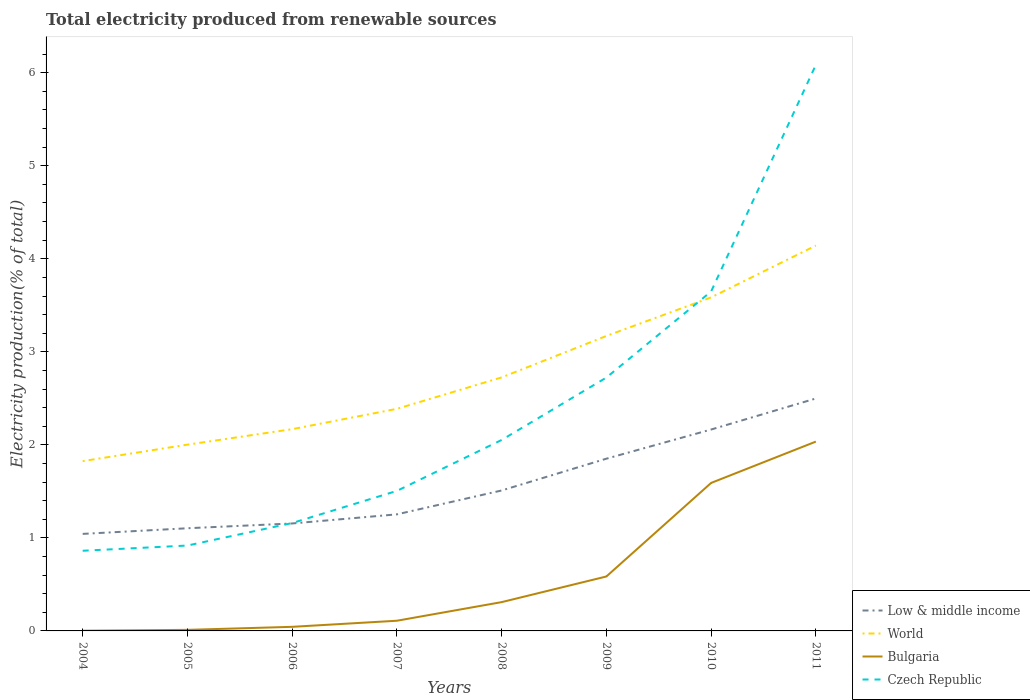Is the number of lines equal to the number of legend labels?
Offer a terse response. Yes. Across all years, what is the maximum total electricity produced in Bulgaria?
Offer a terse response. 0. In which year was the total electricity produced in Czech Republic maximum?
Your answer should be very brief. 2004. What is the total total electricity produced in World in the graph?
Provide a succinct answer. -0.17. What is the difference between the highest and the second highest total electricity produced in Bulgaria?
Keep it short and to the point. 2.03. What is the difference between the highest and the lowest total electricity produced in World?
Keep it short and to the point. 3. Is the total electricity produced in Czech Republic strictly greater than the total electricity produced in Bulgaria over the years?
Provide a short and direct response. No. How many lines are there?
Offer a very short reply. 4. How many years are there in the graph?
Make the answer very short. 8. Are the values on the major ticks of Y-axis written in scientific E-notation?
Your response must be concise. No. Does the graph contain grids?
Offer a terse response. No. Where does the legend appear in the graph?
Give a very brief answer. Bottom right. How many legend labels are there?
Give a very brief answer. 4. How are the legend labels stacked?
Offer a terse response. Vertical. What is the title of the graph?
Ensure brevity in your answer.  Total electricity produced from renewable sources. What is the label or title of the X-axis?
Offer a terse response. Years. What is the label or title of the Y-axis?
Give a very brief answer. Electricity production(% of total). What is the Electricity production(% of total) in Low & middle income in 2004?
Ensure brevity in your answer.  1.04. What is the Electricity production(% of total) of World in 2004?
Give a very brief answer. 1.83. What is the Electricity production(% of total) of Bulgaria in 2004?
Your response must be concise. 0. What is the Electricity production(% of total) of Czech Republic in 2004?
Keep it short and to the point. 0.86. What is the Electricity production(% of total) of Low & middle income in 2005?
Ensure brevity in your answer.  1.1. What is the Electricity production(% of total) in World in 2005?
Keep it short and to the point. 2. What is the Electricity production(% of total) of Bulgaria in 2005?
Your response must be concise. 0.01. What is the Electricity production(% of total) of Czech Republic in 2005?
Give a very brief answer. 0.92. What is the Electricity production(% of total) in Low & middle income in 2006?
Give a very brief answer. 1.16. What is the Electricity production(% of total) of World in 2006?
Provide a short and direct response. 2.17. What is the Electricity production(% of total) of Bulgaria in 2006?
Keep it short and to the point. 0.04. What is the Electricity production(% of total) of Czech Republic in 2006?
Your response must be concise. 1.16. What is the Electricity production(% of total) in Low & middle income in 2007?
Your response must be concise. 1.25. What is the Electricity production(% of total) in World in 2007?
Provide a succinct answer. 2.39. What is the Electricity production(% of total) in Bulgaria in 2007?
Your response must be concise. 0.11. What is the Electricity production(% of total) of Czech Republic in 2007?
Your response must be concise. 1.51. What is the Electricity production(% of total) of Low & middle income in 2008?
Your answer should be compact. 1.51. What is the Electricity production(% of total) of World in 2008?
Provide a succinct answer. 2.72. What is the Electricity production(% of total) of Bulgaria in 2008?
Offer a terse response. 0.31. What is the Electricity production(% of total) of Czech Republic in 2008?
Make the answer very short. 2.05. What is the Electricity production(% of total) in Low & middle income in 2009?
Your response must be concise. 1.85. What is the Electricity production(% of total) of World in 2009?
Give a very brief answer. 3.17. What is the Electricity production(% of total) of Bulgaria in 2009?
Your response must be concise. 0.59. What is the Electricity production(% of total) of Czech Republic in 2009?
Offer a very short reply. 2.72. What is the Electricity production(% of total) in Low & middle income in 2010?
Make the answer very short. 2.16. What is the Electricity production(% of total) in World in 2010?
Give a very brief answer. 3.58. What is the Electricity production(% of total) in Bulgaria in 2010?
Provide a short and direct response. 1.59. What is the Electricity production(% of total) in Czech Republic in 2010?
Offer a terse response. 3.65. What is the Electricity production(% of total) in Low & middle income in 2011?
Your answer should be compact. 2.5. What is the Electricity production(% of total) of World in 2011?
Keep it short and to the point. 4.14. What is the Electricity production(% of total) in Bulgaria in 2011?
Ensure brevity in your answer.  2.04. What is the Electricity production(% of total) in Czech Republic in 2011?
Offer a very short reply. 6.08. Across all years, what is the maximum Electricity production(% of total) of Low & middle income?
Offer a very short reply. 2.5. Across all years, what is the maximum Electricity production(% of total) of World?
Your answer should be compact. 4.14. Across all years, what is the maximum Electricity production(% of total) of Bulgaria?
Provide a succinct answer. 2.04. Across all years, what is the maximum Electricity production(% of total) in Czech Republic?
Provide a succinct answer. 6.08. Across all years, what is the minimum Electricity production(% of total) in Low & middle income?
Offer a terse response. 1.04. Across all years, what is the minimum Electricity production(% of total) in World?
Provide a short and direct response. 1.83. Across all years, what is the minimum Electricity production(% of total) in Bulgaria?
Ensure brevity in your answer.  0. Across all years, what is the minimum Electricity production(% of total) of Czech Republic?
Provide a short and direct response. 0.86. What is the total Electricity production(% of total) in Low & middle income in the graph?
Offer a very short reply. 12.58. What is the total Electricity production(% of total) in World in the graph?
Keep it short and to the point. 22.01. What is the total Electricity production(% of total) in Bulgaria in the graph?
Offer a very short reply. 4.69. What is the total Electricity production(% of total) in Czech Republic in the graph?
Provide a short and direct response. 18.95. What is the difference between the Electricity production(% of total) of Low & middle income in 2004 and that in 2005?
Make the answer very short. -0.06. What is the difference between the Electricity production(% of total) in World in 2004 and that in 2005?
Ensure brevity in your answer.  -0.18. What is the difference between the Electricity production(% of total) of Bulgaria in 2004 and that in 2005?
Offer a terse response. -0.01. What is the difference between the Electricity production(% of total) of Czech Republic in 2004 and that in 2005?
Give a very brief answer. -0.06. What is the difference between the Electricity production(% of total) of Low & middle income in 2004 and that in 2006?
Provide a short and direct response. -0.11. What is the difference between the Electricity production(% of total) of World in 2004 and that in 2006?
Provide a short and direct response. -0.34. What is the difference between the Electricity production(% of total) of Bulgaria in 2004 and that in 2006?
Offer a terse response. -0.04. What is the difference between the Electricity production(% of total) in Czech Republic in 2004 and that in 2006?
Provide a succinct answer. -0.3. What is the difference between the Electricity production(% of total) of Low & middle income in 2004 and that in 2007?
Keep it short and to the point. -0.21. What is the difference between the Electricity production(% of total) of World in 2004 and that in 2007?
Offer a terse response. -0.56. What is the difference between the Electricity production(% of total) of Bulgaria in 2004 and that in 2007?
Offer a terse response. -0.11. What is the difference between the Electricity production(% of total) in Czech Republic in 2004 and that in 2007?
Your answer should be very brief. -0.64. What is the difference between the Electricity production(% of total) in Low & middle income in 2004 and that in 2008?
Ensure brevity in your answer.  -0.47. What is the difference between the Electricity production(% of total) of World in 2004 and that in 2008?
Provide a succinct answer. -0.9. What is the difference between the Electricity production(% of total) in Bulgaria in 2004 and that in 2008?
Your response must be concise. -0.31. What is the difference between the Electricity production(% of total) in Czech Republic in 2004 and that in 2008?
Give a very brief answer. -1.19. What is the difference between the Electricity production(% of total) of Low & middle income in 2004 and that in 2009?
Your response must be concise. -0.81. What is the difference between the Electricity production(% of total) of World in 2004 and that in 2009?
Your answer should be compact. -1.35. What is the difference between the Electricity production(% of total) in Bulgaria in 2004 and that in 2009?
Your answer should be compact. -0.58. What is the difference between the Electricity production(% of total) in Czech Republic in 2004 and that in 2009?
Keep it short and to the point. -1.86. What is the difference between the Electricity production(% of total) in Low & middle income in 2004 and that in 2010?
Ensure brevity in your answer.  -1.12. What is the difference between the Electricity production(% of total) of World in 2004 and that in 2010?
Offer a very short reply. -1.76. What is the difference between the Electricity production(% of total) in Bulgaria in 2004 and that in 2010?
Provide a short and direct response. -1.59. What is the difference between the Electricity production(% of total) of Czech Republic in 2004 and that in 2010?
Ensure brevity in your answer.  -2.79. What is the difference between the Electricity production(% of total) of Low & middle income in 2004 and that in 2011?
Your response must be concise. -1.46. What is the difference between the Electricity production(% of total) of World in 2004 and that in 2011?
Your answer should be very brief. -2.32. What is the difference between the Electricity production(% of total) in Bulgaria in 2004 and that in 2011?
Ensure brevity in your answer.  -2.03. What is the difference between the Electricity production(% of total) of Czech Republic in 2004 and that in 2011?
Offer a terse response. -5.22. What is the difference between the Electricity production(% of total) of Low & middle income in 2005 and that in 2006?
Give a very brief answer. -0.05. What is the difference between the Electricity production(% of total) of World in 2005 and that in 2006?
Provide a short and direct response. -0.17. What is the difference between the Electricity production(% of total) of Bulgaria in 2005 and that in 2006?
Give a very brief answer. -0.03. What is the difference between the Electricity production(% of total) of Czech Republic in 2005 and that in 2006?
Provide a short and direct response. -0.24. What is the difference between the Electricity production(% of total) of Low & middle income in 2005 and that in 2007?
Your response must be concise. -0.15. What is the difference between the Electricity production(% of total) in World in 2005 and that in 2007?
Your response must be concise. -0.39. What is the difference between the Electricity production(% of total) of Bulgaria in 2005 and that in 2007?
Your answer should be very brief. -0.1. What is the difference between the Electricity production(% of total) of Czech Republic in 2005 and that in 2007?
Ensure brevity in your answer.  -0.59. What is the difference between the Electricity production(% of total) in Low & middle income in 2005 and that in 2008?
Keep it short and to the point. -0.41. What is the difference between the Electricity production(% of total) of World in 2005 and that in 2008?
Give a very brief answer. -0.72. What is the difference between the Electricity production(% of total) of Bulgaria in 2005 and that in 2008?
Provide a short and direct response. -0.3. What is the difference between the Electricity production(% of total) in Czech Republic in 2005 and that in 2008?
Offer a terse response. -1.13. What is the difference between the Electricity production(% of total) of Low & middle income in 2005 and that in 2009?
Your answer should be compact. -0.75. What is the difference between the Electricity production(% of total) in World in 2005 and that in 2009?
Keep it short and to the point. -1.17. What is the difference between the Electricity production(% of total) in Bulgaria in 2005 and that in 2009?
Ensure brevity in your answer.  -0.57. What is the difference between the Electricity production(% of total) of Czech Republic in 2005 and that in 2009?
Make the answer very short. -1.81. What is the difference between the Electricity production(% of total) in Low & middle income in 2005 and that in 2010?
Offer a terse response. -1.06. What is the difference between the Electricity production(% of total) in World in 2005 and that in 2010?
Provide a succinct answer. -1.58. What is the difference between the Electricity production(% of total) of Bulgaria in 2005 and that in 2010?
Your response must be concise. -1.58. What is the difference between the Electricity production(% of total) in Czech Republic in 2005 and that in 2010?
Offer a terse response. -2.73. What is the difference between the Electricity production(% of total) in Low & middle income in 2005 and that in 2011?
Your response must be concise. -1.39. What is the difference between the Electricity production(% of total) in World in 2005 and that in 2011?
Offer a very short reply. -2.14. What is the difference between the Electricity production(% of total) in Bulgaria in 2005 and that in 2011?
Your response must be concise. -2.02. What is the difference between the Electricity production(% of total) in Czech Republic in 2005 and that in 2011?
Offer a terse response. -5.17. What is the difference between the Electricity production(% of total) in Low & middle income in 2006 and that in 2007?
Keep it short and to the point. -0.1. What is the difference between the Electricity production(% of total) of World in 2006 and that in 2007?
Your response must be concise. -0.22. What is the difference between the Electricity production(% of total) in Bulgaria in 2006 and that in 2007?
Provide a succinct answer. -0.07. What is the difference between the Electricity production(% of total) of Czech Republic in 2006 and that in 2007?
Offer a very short reply. -0.35. What is the difference between the Electricity production(% of total) of Low & middle income in 2006 and that in 2008?
Your response must be concise. -0.35. What is the difference between the Electricity production(% of total) in World in 2006 and that in 2008?
Your answer should be very brief. -0.56. What is the difference between the Electricity production(% of total) in Bulgaria in 2006 and that in 2008?
Your answer should be very brief. -0.27. What is the difference between the Electricity production(% of total) in Czech Republic in 2006 and that in 2008?
Offer a very short reply. -0.89. What is the difference between the Electricity production(% of total) of Low & middle income in 2006 and that in 2009?
Offer a very short reply. -0.7. What is the difference between the Electricity production(% of total) of World in 2006 and that in 2009?
Offer a terse response. -1. What is the difference between the Electricity production(% of total) in Bulgaria in 2006 and that in 2009?
Give a very brief answer. -0.54. What is the difference between the Electricity production(% of total) in Czech Republic in 2006 and that in 2009?
Your answer should be compact. -1.56. What is the difference between the Electricity production(% of total) in Low & middle income in 2006 and that in 2010?
Make the answer very short. -1.01. What is the difference between the Electricity production(% of total) of World in 2006 and that in 2010?
Make the answer very short. -1.42. What is the difference between the Electricity production(% of total) in Bulgaria in 2006 and that in 2010?
Provide a short and direct response. -1.55. What is the difference between the Electricity production(% of total) of Czech Republic in 2006 and that in 2010?
Your answer should be compact. -2.49. What is the difference between the Electricity production(% of total) in Low & middle income in 2006 and that in 2011?
Your response must be concise. -1.34. What is the difference between the Electricity production(% of total) of World in 2006 and that in 2011?
Provide a short and direct response. -1.97. What is the difference between the Electricity production(% of total) of Bulgaria in 2006 and that in 2011?
Provide a short and direct response. -1.99. What is the difference between the Electricity production(% of total) in Czech Republic in 2006 and that in 2011?
Give a very brief answer. -4.92. What is the difference between the Electricity production(% of total) of Low & middle income in 2007 and that in 2008?
Offer a terse response. -0.26. What is the difference between the Electricity production(% of total) in World in 2007 and that in 2008?
Ensure brevity in your answer.  -0.34. What is the difference between the Electricity production(% of total) of Bulgaria in 2007 and that in 2008?
Provide a short and direct response. -0.2. What is the difference between the Electricity production(% of total) in Czech Republic in 2007 and that in 2008?
Keep it short and to the point. -0.55. What is the difference between the Electricity production(% of total) of Low & middle income in 2007 and that in 2009?
Provide a succinct answer. -0.6. What is the difference between the Electricity production(% of total) of World in 2007 and that in 2009?
Ensure brevity in your answer.  -0.78. What is the difference between the Electricity production(% of total) in Bulgaria in 2007 and that in 2009?
Your answer should be very brief. -0.48. What is the difference between the Electricity production(% of total) in Czech Republic in 2007 and that in 2009?
Provide a short and direct response. -1.22. What is the difference between the Electricity production(% of total) in Low & middle income in 2007 and that in 2010?
Make the answer very short. -0.91. What is the difference between the Electricity production(% of total) of World in 2007 and that in 2010?
Your answer should be very brief. -1.2. What is the difference between the Electricity production(% of total) of Bulgaria in 2007 and that in 2010?
Offer a very short reply. -1.48. What is the difference between the Electricity production(% of total) in Czech Republic in 2007 and that in 2010?
Ensure brevity in your answer.  -2.14. What is the difference between the Electricity production(% of total) of Low & middle income in 2007 and that in 2011?
Give a very brief answer. -1.25. What is the difference between the Electricity production(% of total) of World in 2007 and that in 2011?
Your answer should be very brief. -1.75. What is the difference between the Electricity production(% of total) in Bulgaria in 2007 and that in 2011?
Give a very brief answer. -1.93. What is the difference between the Electricity production(% of total) of Czech Republic in 2007 and that in 2011?
Provide a succinct answer. -4.58. What is the difference between the Electricity production(% of total) of Low & middle income in 2008 and that in 2009?
Give a very brief answer. -0.34. What is the difference between the Electricity production(% of total) of World in 2008 and that in 2009?
Make the answer very short. -0.45. What is the difference between the Electricity production(% of total) in Bulgaria in 2008 and that in 2009?
Ensure brevity in your answer.  -0.28. What is the difference between the Electricity production(% of total) of Czech Republic in 2008 and that in 2009?
Make the answer very short. -0.67. What is the difference between the Electricity production(% of total) of Low & middle income in 2008 and that in 2010?
Keep it short and to the point. -0.66. What is the difference between the Electricity production(% of total) in World in 2008 and that in 2010?
Make the answer very short. -0.86. What is the difference between the Electricity production(% of total) in Bulgaria in 2008 and that in 2010?
Your response must be concise. -1.28. What is the difference between the Electricity production(% of total) of Czech Republic in 2008 and that in 2010?
Your answer should be compact. -1.6. What is the difference between the Electricity production(% of total) in Low & middle income in 2008 and that in 2011?
Your answer should be compact. -0.99. What is the difference between the Electricity production(% of total) of World in 2008 and that in 2011?
Your answer should be compact. -1.42. What is the difference between the Electricity production(% of total) in Bulgaria in 2008 and that in 2011?
Provide a succinct answer. -1.73. What is the difference between the Electricity production(% of total) in Czech Republic in 2008 and that in 2011?
Your answer should be very brief. -4.03. What is the difference between the Electricity production(% of total) of Low & middle income in 2009 and that in 2010?
Your response must be concise. -0.31. What is the difference between the Electricity production(% of total) of World in 2009 and that in 2010?
Make the answer very short. -0.41. What is the difference between the Electricity production(% of total) of Bulgaria in 2009 and that in 2010?
Make the answer very short. -1.01. What is the difference between the Electricity production(% of total) in Czech Republic in 2009 and that in 2010?
Your answer should be compact. -0.93. What is the difference between the Electricity production(% of total) in Low & middle income in 2009 and that in 2011?
Your answer should be compact. -0.65. What is the difference between the Electricity production(% of total) of World in 2009 and that in 2011?
Provide a succinct answer. -0.97. What is the difference between the Electricity production(% of total) of Bulgaria in 2009 and that in 2011?
Your answer should be compact. -1.45. What is the difference between the Electricity production(% of total) of Czech Republic in 2009 and that in 2011?
Your answer should be very brief. -3.36. What is the difference between the Electricity production(% of total) in Low & middle income in 2010 and that in 2011?
Ensure brevity in your answer.  -0.33. What is the difference between the Electricity production(% of total) in World in 2010 and that in 2011?
Make the answer very short. -0.56. What is the difference between the Electricity production(% of total) of Bulgaria in 2010 and that in 2011?
Provide a short and direct response. -0.44. What is the difference between the Electricity production(% of total) in Czech Republic in 2010 and that in 2011?
Keep it short and to the point. -2.44. What is the difference between the Electricity production(% of total) of Low & middle income in 2004 and the Electricity production(% of total) of World in 2005?
Provide a succinct answer. -0.96. What is the difference between the Electricity production(% of total) of Low & middle income in 2004 and the Electricity production(% of total) of Bulgaria in 2005?
Make the answer very short. 1.03. What is the difference between the Electricity production(% of total) in Low & middle income in 2004 and the Electricity production(% of total) in Czech Republic in 2005?
Your answer should be very brief. 0.13. What is the difference between the Electricity production(% of total) of World in 2004 and the Electricity production(% of total) of Bulgaria in 2005?
Give a very brief answer. 1.81. What is the difference between the Electricity production(% of total) of World in 2004 and the Electricity production(% of total) of Czech Republic in 2005?
Provide a short and direct response. 0.91. What is the difference between the Electricity production(% of total) in Bulgaria in 2004 and the Electricity production(% of total) in Czech Republic in 2005?
Your response must be concise. -0.92. What is the difference between the Electricity production(% of total) in Low & middle income in 2004 and the Electricity production(% of total) in World in 2006?
Your response must be concise. -1.13. What is the difference between the Electricity production(% of total) of Low & middle income in 2004 and the Electricity production(% of total) of Bulgaria in 2006?
Ensure brevity in your answer.  1. What is the difference between the Electricity production(% of total) of Low & middle income in 2004 and the Electricity production(% of total) of Czech Republic in 2006?
Your answer should be compact. -0.12. What is the difference between the Electricity production(% of total) in World in 2004 and the Electricity production(% of total) in Bulgaria in 2006?
Give a very brief answer. 1.78. What is the difference between the Electricity production(% of total) in World in 2004 and the Electricity production(% of total) in Czech Republic in 2006?
Your answer should be compact. 0.67. What is the difference between the Electricity production(% of total) of Bulgaria in 2004 and the Electricity production(% of total) of Czech Republic in 2006?
Ensure brevity in your answer.  -1.16. What is the difference between the Electricity production(% of total) in Low & middle income in 2004 and the Electricity production(% of total) in World in 2007?
Provide a short and direct response. -1.34. What is the difference between the Electricity production(% of total) of Low & middle income in 2004 and the Electricity production(% of total) of Bulgaria in 2007?
Your answer should be very brief. 0.93. What is the difference between the Electricity production(% of total) of Low & middle income in 2004 and the Electricity production(% of total) of Czech Republic in 2007?
Give a very brief answer. -0.46. What is the difference between the Electricity production(% of total) of World in 2004 and the Electricity production(% of total) of Bulgaria in 2007?
Give a very brief answer. 1.72. What is the difference between the Electricity production(% of total) in World in 2004 and the Electricity production(% of total) in Czech Republic in 2007?
Your answer should be very brief. 0.32. What is the difference between the Electricity production(% of total) in Bulgaria in 2004 and the Electricity production(% of total) in Czech Republic in 2007?
Offer a terse response. -1.5. What is the difference between the Electricity production(% of total) of Low & middle income in 2004 and the Electricity production(% of total) of World in 2008?
Your answer should be very brief. -1.68. What is the difference between the Electricity production(% of total) of Low & middle income in 2004 and the Electricity production(% of total) of Bulgaria in 2008?
Offer a terse response. 0.73. What is the difference between the Electricity production(% of total) in Low & middle income in 2004 and the Electricity production(% of total) in Czech Republic in 2008?
Ensure brevity in your answer.  -1.01. What is the difference between the Electricity production(% of total) in World in 2004 and the Electricity production(% of total) in Bulgaria in 2008?
Your answer should be compact. 1.52. What is the difference between the Electricity production(% of total) in World in 2004 and the Electricity production(% of total) in Czech Republic in 2008?
Give a very brief answer. -0.23. What is the difference between the Electricity production(% of total) in Bulgaria in 2004 and the Electricity production(% of total) in Czech Republic in 2008?
Your answer should be very brief. -2.05. What is the difference between the Electricity production(% of total) in Low & middle income in 2004 and the Electricity production(% of total) in World in 2009?
Give a very brief answer. -2.13. What is the difference between the Electricity production(% of total) of Low & middle income in 2004 and the Electricity production(% of total) of Bulgaria in 2009?
Provide a short and direct response. 0.46. What is the difference between the Electricity production(% of total) in Low & middle income in 2004 and the Electricity production(% of total) in Czech Republic in 2009?
Give a very brief answer. -1.68. What is the difference between the Electricity production(% of total) in World in 2004 and the Electricity production(% of total) in Bulgaria in 2009?
Your answer should be compact. 1.24. What is the difference between the Electricity production(% of total) in World in 2004 and the Electricity production(% of total) in Czech Republic in 2009?
Provide a short and direct response. -0.9. What is the difference between the Electricity production(% of total) in Bulgaria in 2004 and the Electricity production(% of total) in Czech Republic in 2009?
Provide a succinct answer. -2.72. What is the difference between the Electricity production(% of total) in Low & middle income in 2004 and the Electricity production(% of total) in World in 2010?
Provide a succinct answer. -2.54. What is the difference between the Electricity production(% of total) of Low & middle income in 2004 and the Electricity production(% of total) of Bulgaria in 2010?
Make the answer very short. -0.55. What is the difference between the Electricity production(% of total) in Low & middle income in 2004 and the Electricity production(% of total) in Czech Republic in 2010?
Your answer should be very brief. -2.61. What is the difference between the Electricity production(% of total) in World in 2004 and the Electricity production(% of total) in Bulgaria in 2010?
Keep it short and to the point. 0.23. What is the difference between the Electricity production(% of total) of World in 2004 and the Electricity production(% of total) of Czech Republic in 2010?
Your answer should be very brief. -1.82. What is the difference between the Electricity production(% of total) of Bulgaria in 2004 and the Electricity production(% of total) of Czech Republic in 2010?
Offer a very short reply. -3.65. What is the difference between the Electricity production(% of total) of Low & middle income in 2004 and the Electricity production(% of total) of World in 2011?
Your answer should be compact. -3.1. What is the difference between the Electricity production(% of total) in Low & middle income in 2004 and the Electricity production(% of total) in Bulgaria in 2011?
Offer a terse response. -0.99. What is the difference between the Electricity production(% of total) in Low & middle income in 2004 and the Electricity production(% of total) in Czech Republic in 2011?
Provide a succinct answer. -5.04. What is the difference between the Electricity production(% of total) in World in 2004 and the Electricity production(% of total) in Bulgaria in 2011?
Your answer should be compact. -0.21. What is the difference between the Electricity production(% of total) of World in 2004 and the Electricity production(% of total) of Czech Republic in 2011?
Ensure brevity in your answer.  -4.26. What is the difference between the Electricity production(% of total) of Bulgaria in 2004 and the Electricity production(% of total) of Czech Republic in 2011?
Offer a terse response. -6.08. What is the difference between the Electricity production(% of total) of Low & middle income in 2005 and the Electricity production(% of total) of World in 2006?
Your response must be concise. -1.06. What is the difference between the Electricity production(% of total) in Low & middle income in 2005 and the Electricity production(% of total) in Bulgaria in 2006?
Make the answer very short. 1.06. What is the difference between the Electricity production(% of total) in Low & middle income in 2005 and the Electricity production(% of total) in Czech Republic in 2006?
Your response must be concise. -0.06. What is the difference between the Electricity production(% of total) in World in 2005 and the Electricity production(% of total) in Bulgaria in 2006?
Offer a terse response. 1.96. What is the difference between the Electricity production(% of total) in World in 2005 and the Electricity production(% of total) in Czech Republic in 2006?
Give a very brief answer. 0.84. What is the difference between the Electricity production(% of total) in Bulgaria in 2005 and the Electricity production(% of total) in Czech Republic in 2006?
Offer a very short reply. -1.15. What is the difference between the Electricity production(% of total) of Low & middle income in 2005 and the Electricity production(% of total) of World in 2007?
Make the answer very short. -1.28. What is the difference between the Electricity production(% of total) of Low & middle income in 2005 and the Electricity production(% of total) of Czech Republic in 2007?
Offer a very short reply. -0.4. What is the difference between the Electricity production(% of total) of World in 2005 and the Electricity production(% of total) of Bulgaria in 2007?
Provide a short and direct response. 1.89. What is the difference between the Electricity production(% of total) of World in 2005 and the Electricity production(% of total) of Czech Republic in 2007?
Offer a terse response. 0.5. What is the difference between the Electricity production(% of total) in Bulgaria in 2005 and the Electricity production(% of total) in Czech Republic in 2007?
Your answer should be compact. -1.49. What is the difference between the Electricity production(% of total) of Low & middle income in 2005 and the Electricity production(% of total) of World in 2008?
Offer a terse response. -1.62. What is the difference between the Electricity production(% of total) in Low & middle income in 2005 and the Electricity production(% of total) in Bulgaria in 2008?
Offer a very short reply. 0.79. What is the difference between the Electricity production(% of total) of Low & middle income in 2005 and the Electricity production(% of total) of Czech Republic in 2008?
Make the answer very short. -0.95. What is the difference between the Electricity production(% of total) in World in 2005 and the Electricity production(% of total) in Bulgaria in 2008?
Make the answer very short. 1.69. What is the difference between the Electricity production(% of total) in World in 2005 and the Electricity production(% of total) in Czech Republic in 2008?
Ensure brevity in your answer.  -0.05. What is the difference between the Electricity production(% of total) of Bulgaria in 2005 and the Electricity production(% of total) of Czech Republic in 2008?
Your answer should be compact. -2.04. What is the difference between the Electricity production(% of total) of Low & middle income in 2005 and the Electricity production(% of total) of World in 2009?
Your response must be concise. -2.07. What is the difference between the Electricity production(% of total) of Low & middle income in 2005 and the Electricity production(% of total) of Bulgaria in 2009?
Give a very brief answer. 0.52. What is the difference between the Electricity production(% of total) of Low & middle income in 2005 and the Electricity production(% of total) of Czech Republic in 2009?
Provide a short and direct response. -1.62. What is the difference between the Electricity production(% of total) of World in 2005 and the Electricity production(% of total) of Bulgaria in 2009?
Your answer should be very brief. 1.42. What is the difference between the Electricity production(% of total) of World in 2005 and the Electricity production(% of total) of Czech Republic in 2009?
Ensure brevity in your answer.  -0.72. What is the difference between the Electricity production(% of total) in Bulgaria in 2005 and the Electricity production(% of total) in Czech Republic in 2009?
Your answer should be very brief. -2.71. What is the difference between the Electricity production(% of total) of Low & middle income in 2005 and the Electricity production(% of total) of World in 2010?
Make the answer very short. -2.48. What is the difference between the Electricity production(% of total) of Low & middle income in 2005 and the Electricity production(% of total) of Bulgaria in 2010?
Give a very brief answer. -0.49. What is the difference between the Electricity production(% of total) of Low & middle income in 2005 and the Electricity production(% of total) of Czech Republic in 2010?
Ensure brevity in your answer.  -2.55. What is the difference between the Electricity production(% of total) in World in 2005 and the Electricity production(% of total) in Bulgaria in 2010?
Offer a terse response. 0.41. What is the difference between the Electricity production(% of total) in World in 2005 and the Electricity production(% of total) in Czech Republic in 2010?
Make the answer very short. -1.65. What is the difference between the Electricity production(% of total) of Bulgaria in 2005 and the Electricity production(% of total) of Czech Republic in 2010?
Your answer should be compact. -3.64. What is the difference between the Electricity production(% of total) in Low & middle income in 2005 and the Electricity production(% of total) in World in 2011?
Provide a succinct answer. -3.04. What is the difference between the Electricity production(% of total) in Low & middle income in 2005 and the Electricity production(% of total) in Bulgaria in 2011?
Your response must be concise. -0.93. What is the difference between the Electricity production(% of total) of Low & middle income in 2005 and the Electricity production(% of total) of Czech Republic in 2011?
Keep it short and to the point. -4.98. What is the difference between the Electricity production(% of total) of World in 2005 and the Electricity production(% of total) of Bulgaria in 2011?
Your answer should be compact. -0.03. What is the difference between the Electricity production(% of total) of World in 2005 and the Electricity production(% of total) of Czech Republic in 2011?
Provide a succinct answer. -4.08. What is the difference between the Electricity production(% of total) of Bulgaria in 2005 and the Electricity production(% of total) of Czech Republic in 2011?
Your response must be concise. -6.07. What is the difference between the Electricity production(% of total) of Low & middle income in 2006 and the Electricity production(% of total) of World in 2007?
Give a very brief answer. -1.23. What is the difference between the Electricity production(% of total) of Low & middle income in 2006 and the Electricity production(% of total) of Bulgaria in 2007?
Your response must be concise. 1.05. What is the difference between the Electricity production(% of total) of Low & middle income in 2006 and the Electricity production(% of total) of Czech Republic in 2007?
Your answer should be compact. -0.35. What is the difference between the Electricity production(% of total) of World in 2006 and the Electricity production(% of total) of Bulgaria in 2007?
Your answer should be very brief. 2.06. What is the difference between the Electricity production(% of total) in World in 2006 and the Electricity production(% of total) in Czech Republic in 2007?
Provide a succinct answer. 0.66. What is the difference between the Electricity production(% of total) in Bulgaria in 2006 and the Electricity production(% of total) in Czech Republic in 2007?
Provide a short and direct response. -1.46. What is the difference between the Electricity production(% of total) of Low & middle income in 2006 and the Electricity production(% of total) of World in 2008?
Provide a short and direct response. -1.57. What is the difference between the Electricity production(% of total) in Low & middle income in 2006 and the Electricity production(% of total) in Bulgaria in 2008?
Your answer should be compact. 0.85. What is the difference between the Electricity production(% of total) in Low & middle income in 2006 and the Electricity production(% of total) in Czech Republic in 2008?
Give a very brief answer. -0.9. What is the difference between the Electricity production(% of total) in World in 2006 and the Electricity production(% of total) in Bulgaria in 2008?
Keep it short and to the point. 1.86. What is the difference between the Electricity production(% of total) of World in 2006 and the Electricity production(% of total) of Czech Republic in 2008?
Keep it short and to the point. 0.12. What is the difference between the Electricity production(% of total) of Bulgaria in 2006 and the Electricity production(% of total) of Czech Republic in 2008?
Offer a terse response. -2.01. What is the difference between the Electricity production(% of total) in Low & middle income in 2006 and the Electricity production(% of total) in World in 2009?
Your answer should be very brief. -2.02. What is the difference between the Electricity production(% of total) of Low & middle income in 2006 and the Electricity production(% of total) of Bulgaria in 2009?
Your response must be concise. 0.57. What is the difference between the Electricity production(% of total) of Low & middle income in 2006 and the Electricity production(% of total) of Czech Republic in 2009?
Make the answer very short. -1.57. What is the difference between the Electricity production(% of total) in World in 2006 and the Electricity production(% of total) in Bulgaria in 2009?
Offer a terse response. 1.58. What is the difference between the Electricity production(% of total) of World in 2006 and the Electricity production(% of total) of Czech Republic in 2009?
Your response must be concise. -0.55. What is the difference between the Electricity production(% of total) of Bulgaria in 2006 and the Electricity production(% of total) of Czech Republic in 2009?
Offer a very short reply. -2.68. What is the difference between the Electricity production(% of total) of Low & middle income in 2006 and the Electricity production(% of total) of World in 2010?
Your response must be concise. -2.43. What is the difference between the Electricity production(% of total) of Low & middle income in 2006 and the Electricity production(% of total) of Bulgaria in 2010?
Make the answer very short. -0.44. What is the difference between the Electricity production(% of total) in Low & middle income in 2006 and the Electricity production(% of total) in Czech Republic in 2010?
Your answer should be very brief. -2.49. What is the difference between the Electricity production(% of total) of World in 2006 and the Electricity production(% of total) of Bulgaria in 2010?
Your answer should be very brief. 0.58. What is the difference between the Electricity production(% of total) of World in 2006 and the Electricity production(% of total) of Czech Republic in 2010?
Offer a very short reply. -1.48. What is the difference between the Electricity production(% of total) of Bulgaria in 2006 and the Electricity production(% of total) of Czech Republic in 2010?
Offer a very short reply. -3.6. What is the difference between the Electricity production(% of total) in Low & middle income in 2006 and the Electricity production(% of total) in World in 2011?
Offer a terse response. -2.99. What is the difference between the Electricity production(% of total) of Low & middle income in 2006 and the Electricity production(% of total) of Bulgaria in 2011?
Offer a very short reply. -0.88. What is the difference between the Electricity production(% of total) in Low & middle income in 2006 and the Electricity production(% of total) in Czech Republic in 2011?
Provide a short and direct response. -4.93. What is the difference between the Electricity production(% of total) in World in 2006 and the Electricity production(% of total) in Bulgaria in 2011?
Give a very brief answer. 0.13. What is the difference between the Electricity production(% of total) of World in 2006 and the Electricity production(% of total) of Czech Republic in 2011?
Offer a very short reply. -3.92. What is the difference between the Electricity production(% of total) of Bulgaria in 2006 and the Electricity production(% of total) of Czech Republic in 2011?
Provide a succinct answer. -6.04. What is the difference between the Electricity production(% of total) of Low & middle income in 2007 and the Electricity production(% of total) of World in 2008?
Keep it short and to the point. -1.47. What is the difference between the Electricity production(% of total) in Low & middle income in 2007 and the Electricity production(% of total) in Bulgaria in 2008?
Provide a short and direct response. 0.94. What is the difference between the Electricity production(% of total) of Low & middle income in 2007 and the Electricity production(% of total) of Czech Republic in 2008?
Make the answer very short. -0.8. What is the difference between the Electricity production(% of total) of World in 2007 and the Electricity production(% of total) of Bulgaria in 2008?
Keep it short and to the point. 2.08. What is the difference between the Electricity production(% of total) in World in 2007 and the Electricity production(% of total) in Czech Republic in 2008?
Your response must be concise. 0.33. What is the difference between the Electricity production(% of total) in Bulgaria in 2007 and the Electricity production(% of total) in Czech Republic in 2008?
Your answer should be very brief. -1.94. What is the difference between the Electricity production(% of total) in Low & middle income in 2007 and the Electricity production(% of total) in World in 2009?
Keep it short and to the point. -1.92. What is the difference between the Electricity production(% of total) in Low & middle income in 2007 and the Electricity production(% of total) in Bulgaria in 2009?
Your answer should be compact. 0.67. What is the difference between the Electricity production(% of total) of Low & middle income in 2007 and the Electricity production(% of total) of Czech Republic in 2009?
Provide a short and direct response. -1.47. What is the difference between the Electricity production(% of total) of World in 2007 and the Electricity production(% of total) of Bulgaria in 2009?
Your answer should be very brief. 1.8. What is the difference between the Electricity production(% of total) in World in 2007 and the Electricity production(% of total) in Czech Republic in 2009?
Provide a succinct answer. -0.34. What is the difference between the Electricity production(% of total) in Bulgaria in 2007 and the Electricity production(% of total) in Czech Republic in 2009?
Offer a terse response. -2.61. What is the difference between the Electricity production(% of total) in Low & middle income in 2007 and the Electricity production(% of total) in World in 2010?
Offer a terse response. -2.33. What is the difference between the Electricity production(% of total) in Low & middle income in 2007 and the Electricity production(% of total) in Bulgaria in 2010?
Your answer should be very brief. -0.34. What is the difference between the Electricity production(% of total) of Low & middle income in 2007 and the Electricity production(% of total) of Czech Republic in 2010?
Your answer should be very brief. -2.4. What is the difference between the Electricity production(% of total) in World in 2007 and the Electricity production(% of total) in Bulgaria in 2010?
Give a very brief answer. 0.8. What is the difference between the Electricity production(% of total) of World in 2007 and the Electricity production(% of total) of Czech Republic in 2010?
Give a very brief answer. -1.26. What is the difference between the Electricity production(% of total) in Bulgaria in 2007 and the Electricity production(% of total) in Czech Republic in 2010?
Your response must be concise. -3.54. What is the difference between the Electricity production(% of total) of Low & middle income in 2007 and the Electricity production(% of total) of World in 2011?
Give a very brief answer. -2.89. What is the difference between the Electricity production(% of total) in Low & middle income in 2007 and the Electricity production(% of total) in Bulgaria in 2011?
Provide a short and direct response. -0.78. What is the difference between the Electricity production(% of total) of Low & middle income in 2007 and the Electricity production(% of total) of Czech Republic in 2011?
Your answer should be compact. -4.83. What is the difference between the Electricity production(% of total) of World in 2007 and the Electricity production(% of total) of Bulgaria in 2011?
Ensure brevity in your answer.  0.35. What is the difference between the Electricity production(% of total) of World in 2007 and the Electricity production(% of total) of Czech Republic in 2011?
Provide a short and direct response. -3.7. What is the difference between the Electricity production(% of total) in Bulgaria in 2007 and the Electricity production(% of total) in Czech Republic in 2011?
Your answer should be compact. -5.97. What is the difference between the Electricity production(% of total) in Low & middle income in 2008 and the Electricity production(% of total) in World in 2009?
Provide a succinct answer. -1.66. What is the difference between the Electricity production(% of total) of Low & middle income in 2008 and the Electricity production(% of total) of Bulgaria in 2009?
Provide a succinct answer. 0.92. What is the difference between the Electricity production(% of total) of Low & middle income in 2008 and the Electricity production(% of total) of Czech Republic in 2009?
Provide a succinct answer. -1.21. What is the difference between the Electricity production(% of total) of World in 2008 and the Electricity production(% of total) of Bulgaria in 2009?
Make the answer very short. 2.14. What is the difference between the Electricity production(% of total) in World in 2008 and the Electricity production(% of total) in Czech Republic in 2009?
Give a very brief answer. 0. What is the difference between the Electricity production(% of total) of Bulgaria in 2008 and the Electricity production(% of total) of Czech Republic in 2009?
Offer a terse response. -2.41. What is the difference between the Electricity production(% of total) in Low & middle income in 2008 and the Electricity production(% of total) in World in 2010?
Provide a succinct answer. -2.08. What is the difference between the Electricity production(% of total) of Low & middle income in 2008 and the Electricity production(% of total) of Bulgaria in 2010?
Your answer should be very brief. -0.08. What is the difference between the Electricity production(% of total) in Low & middle income in 2008 and the Electricity production(% of total) in Czech Republic in 2010?
Offer a terse response. -2.14. What is the difference between the Electricity production(% of total) in World in 2008 and the Electricity production(% of total) in Bulgaria in 2010?
Ensure brevity in your answer.  1.13. What is the difference between the Electricity production(% of total) of World in 2008 and the Electricity production(% of total) of Czech Republic in 2010?
Offer a terse response. -0.92. What is the difference between the Electricity production(% of total) in Bulgaria in 2008 and the Electricity production(% of total) in Czech Republic in 2010?
Give a very brief answer. -3.34. What is the difference between the Electricity production(% of total) in Low & middle income in 2008 and the Electricity production(% of total) in World in 2011?
Offer a very short reply. -2.63. What is the difference between the Electricity production(% of total) in Low & middle income in 2008 and the Electricity production(% of total) in Bulgaria in 2011?
Your answer should be very brief. -0.53. What is the difference between the Electricity production(% of total) of Low & middle income in 2008 and the Electricity production(% of total) of Czech Republic in 2011?
Make the answer very short. -4.57. What is the difference between the Electricity production(% of total) of World in 2008 and the Electricity production(% of total) of Bulgaria in 2011?
Your answer should be compact. 0.69. What is the difference between the Electricity production(% of total) of World in 2008 and the Electricity production(% of total) of Czech Republic in 2011?
Provide a short and direct response. -3.36. What is the difference between the Electricity production(% of total) in Bulgaria in 2008 and the Electricity production(% of total) in Czech Republic in 2011?
Provide a succinct answer. -5.78. What is the difference between the Electricity production(% of total) in Low & middle income in 2009 and the Electricity production(% of total) in World in 2010?
Offer a very short reply. -1.73. What is the difference between the Electricity production(% of total) in Low & middle income in 2009 and the Electricity production(% of total) in Bulgaria in 2010?
Offer a very short reply. 0.26. What is the difference between the Electricity production(% of total) of Low & middle income in 2009 and the Electricity production(% of total) of Czech Republic in 2010?
Ensure brevity in your answer.  -1.8. What is the difference between the Electricity production(% of total) in World in 2009 and the Electricity production(% of total) in Bulgaria in 2010?
Offer a terse response. 1.58. What is the difference between the Electricity production(% of total) of World in 2009 and the Electricity production(% of total) of Czech Republic in 2010?
Your response must be concise. -0.48. What is the difference between the Electricity production(% of total) of Bulgaria in 2009 and the Electricity production(% of total) of Czech Republic in 2010?
Provide a short and direct response. -3.06. What is the difference between the Electricity production(% of total) in Low & middle income in 2009 and the Electricity production(% of total) in World in 2011?
Your answer should be compact. -2.29. What is the difference between the Electricity production(% of total) in Low & middle income in 2009 and the Electricity production(% of total) in Bulgaria in 2011?
Your answer should be very brief. -0.18. What is the difference between the Electricity production(% of total) in Low & middle income in 2009 and the Electricity production(% of total) in Czech Republic in 2011?
Offer a terse response. -4.23. What is the difference between the Electricity production(% of total) of World in 2009 and the Electricity production(% of total) of Bulgaria in 2011?
Your answer should be compact. 1.14. What is the difference between the Electricity production(% of total) of World in 2009 and the Electricity production(% of total) of Czech Republic in 2011?
Offer a terse response. -2.91. What is the difference between the Electricity production(% of total) in Bulgaria in 2009 and the Electricity production(% of total) in Czech Republic in 2011?
Offer a terse response. -5.5. What is the difference between the Electricity production(% of total) in Low & middle income in 2010 and the Electricity production(% of total) in World in 2011?
Your response must be concise. -1.98. What is the difference between the Electricity production(% of total) of Low & middle income in 2010 and the Electricity production(% of total) of Bulgaria in 2011?
Offer a terse response. 0.13. What is the difference between the Electricity production(% of total) in Low & middle income in 2010 and the Electricity production(% of total) in Czech Republic in 2011?
Your response must be concise. -3.92. What is the difference between the Electricity production(% of total) of World in 2010 and the Electricity production(% of total) of Bulgaria in 2011?
Your response must be concise. 1.55. What is the difference between the Electricity production(% of total) of World in 2010 and the Electricity production(% of total) of Czech Republic in 2011?
Keep it short and to the point. -2.5. What is the difference between the Electricity production(% of total) of Bulgaria in 2010 and the Electricity production(% of total) of Czech Republic in 2011?
Give a very brief answer. -4.49. What is the average Electricity production(% of total) in Low & middle income per year?
Your answer should be compact. 1.57. What is the average Electricity production(% of total) of World per year?
Ensure brevity in your answer.  2.75. What is the average Electricity production(% of total) in Bulgaria per year?
Ensure brevity in your answer.  0.59. What is the average Electricity production(% of total) of Czech Republic per year?
Offer a terse response. 2.37. In the year 2004, what is the difference between the Electricity production(% of total) in Low & middle income and Electricity production(% of total) in World?
Keep it short and to the point. -0.78. In the year 2004, what is the difference between the Electricity production(% of total) of Low & middle income and Electricity production(% of total) of Bulgaria?
Offer a terse response. 1.04. In the year 2004, what is the difference between the Electricity production(% of total) of Low & middle income and Electricity production(% of total) of Czech Republic?
Give a very brief answer. 0.18. In the year 2004, what is the difference between the Electricity production(% of total) in World and Electricity production(% of total) in Bulgaria?
Give a very brief answer. 1.82. In the year 2004, what is the difference between the Electricity production(% of total) of World and Electricity production(% of total) of Czech Republic?
Give a very brief answer. 0.96. In the year 2004, what is the difference between the Electricity production(% of total) of Bulgaria and Electricity production(% of total) of Czech Republic?
Give a very brief answer. -0.86. In the year 2005, what is the difference between the Electricity production(% of total) in Low & middle income and Electricity production(% of total) in World?
Offer a very short reply. -0.9. In the year 2005, what is the difference between the Electricity production(% of total) of Low & middle income and Electricity production(% of total) of Bulgaria?
Ensure brevity in your answer.  1.09. In the year 2005, what is the difference between the Electricity production(% of total) of Low & middle income and Electricity production(% of total) of Czech Republic?
Make the answer very short. 0.19. In the year 2005, what is the difference between the Electricity production(% of total) in World and Electricity production(% of total) in Bulgaria?
Ensure brevity in your answer.  1.99. In the year 2005, what is the difference between the Electricity production(% of total) of World and Electricity production(% of total) of Czech Republic?
Give a very brief answer. 1.08. In the year 2005, what is the difference between the Electricity production(% of total) in Bulgaria and Electricity production(% of total) in Czech Republic?
Provide a short and direct response. -0.91. In the year 2006, what is the difference between the Electricity production(% of total) in Low & middle income and Electricity production(% of total) in World?
Make the answer very short. -1.01. In the year 2006, what is the difference between the Electricity production(% of total) in Low & middle income and Electricity production(% of total) in Bulgaria?
Provide a short and direct response. 1.11. In the year 2006, what is the difference between the Electricity production(% of total) of Low & middle income and Electricity production(% of total) of Czech Republic?
Keep it short and to the point. -0. In the year 2006, what is the difference between the Electricity production(% of total) in World and Electricity production(% of total) in Bulgaria?
Ensure brevity in your answer.  2.12. In the year 2006, what is the difference between the Electricity production(% of total) of World and Electricity production(% of total) of Czech Republic?
Provide a succinct answer. 1.01. In the year 2006, what is the difference between the Electricity production(% of total) of Bulgaria and Electricity production(% of total) of Czech Republic?
Keep it short and to the point. -1.12. In the year 2007, what is the difference between the Electricity production(% of total) in Low & middle income and Electricity production(% of total) in World?
Give a very brief answer. -1.13. In the year 2007, what is the difference between the Electricity production(% of total) in Low & middle income and Electricity production(% of total) in Bulgaria?
Offer a very short reply. 1.14. In the year 2007, what is the difference between the Electricity production(% of total) in Low & middle income and Electricity production(% of total) in Czech Republic?
Ensure brevity in your answer.  -0.25. In the year 2007, what is the difference between the Electricity production(% of total) in World and Electricity production(% of total) in Bulgaria?
Your answer should be compact. 2.28. In the year 2007, what is the difference between the Electricity production(% of total) in World and Electricity production(% of total) in Czech Republic?
Offer a terse response. 0.88. In the year 2007, what is the difference between the Electricity production(% of total) in Bulgaria and Electricity production(% of total) in Czech Republic?
Your answer should be very brief. -1.4. In the year 2008, what is the difference between the Electricity production(% of total) of Low & middle income and Electricity production(% of total) of World?
Offer a very short reply. -1.22. In the year 2008, what is the difference between the Electricity production(% of total) in Low & middle income and Electricity production(% of total) in Bulgaria?
Your answer should be compact. 1.2. In the year 2008, what is the difference between the Electricity production(% of total) of Low & middle income and Electricity production(% of total) of Czech Republic?
Provide a short and direct response. -0.54. In the year 2008, what is the difference between the Electricity production(% of total) in World and Electricity production(% of total) in Bulgaria?
Provide a short and direct response. 2.42. In the year 2008, what is the difference between the Electricity production(% of total) of World and Electricity production(% of total) of Czech Republic?
Your answer should be very brief. 0.67. In the year 2008, what is the difference between the Electricity production(% of total) in Bulgaria and Electricity production(% of total) in Czech Republic?
Make the answer very short. -1.74. In the year 2009, what is the difference between the Electricity production(% of total) of Low & middle income and Electricity production(% of total) of World?
Provide a succinct answer. -1.32. In the year 2009, what is the difference between the Electricity production(% of total) of Low & middle income and Electricity production(% of total) of Bulgaria?
Provide a succinct answer. 1.27. In the year 2009, what is the difference between the Electricity production(% of total) of Low & middle income and Electricity production(% of total) of Czech Republic?
Keep it short and to the point. -0.87. In the year 2009, what is the difference between the Electricity production(% of total) of World and Electricity production(% of total) of Bulgaria?
Make the answer very short. 2.59. In the year 2009, what is the difference between the Electricity production(% of total) of World and Electricity production(% of total) of Czech Republic?
Give a very brief answer. 0.45. In the year 2009, what is the difference between the Electricity production(% of total) in Bulgaria and Electricity production(% of total) in Czech Republic?
Provide a succinct answer. -2.14. In the year 2010, what is the difference between the Electricity production(% of total) of Low & middle income and Electricity production(% of total) of World?
Offer a very short reply. -1.42. In the year 2010, what is the difference between the Electricity production(% of total) of Low & middle income and Electricity production(% of total) of Bulgaria?
Give a very brief answer. 0.57. In the year 2010, what is the difference between the Electricity production(% of total) of Low & middle income and Electricity production(% of total) of Czech Republic?
Provide a succinct answer. -1.48. In the year 2010, what is the difference between the Electricity production(% of total) in World and Electricity production(% of total) in Bulgaria?
Make the answer very short. 1.99. In the year 2010, what is the difference between the Electricity production(% of total) in World and Electricity production(% of total) in Czech Republic?
Make the answer very short. -0.06. In the year 2010, what is the difference between the Electricity production(% of total) in Bulgaria and Electricity production(% of total) in Czech Republic?
Provide a succinct answer. -2.06. In the year 2011, what is the difference between the Electricity production(% of total) in Low & middle income and Electricity production(% of total) in World?
Provide a succinct answer. -1.64. In the year 2011, what is the difference between the Electricity production(% of total) in Low & middle income and Electricity production(% of total) in Bulgaria?
Keep it short and to the point. 0.46. In the year 2011, what is the difference between the Electricity production(% of total) in Low & middle income and Electricity production(% of total) in Czech Republic?
Your answer should be very brief. -3.59. In the year 2011, what is the difference between the Electricity production(% of total) of World and Electricity production(% of total) of Bulgaria?
Provide a succinct answer. 2.11. In the year 2011, what is the difference between the Electricity production(% of total) of World and Electricity production(% of total) of Czech Republic?
Offer a terse response. -1.94. In the year 2011, what is the difference between the Electricity production(% of total) of Bulgaria and Electricity production(% of total) of Czech Republic?
Provide a succinct answer. -4.05. What is the ratio of the Electricity production(% of total) of Low & middle income in 2004 to that in 2005?
Provide a succinct answer. 0.94. What is the ratio of the Electricity production(% of total) of World in 2004 to that in 2005?
Give a very brief answer. 0.91. What is the ratio of the Electricity production(% of total) in Bulgaria in 2004 to that in 2005?
Your response must be concise. 0.21. What is the ratio of the Electricity production(% of total) in Czech Republic in 2004 to that in 2005?
Offer a terse response. 0.94. What is the ratio of the Electricity production(% of total) of Low & middle income in 2004 to that in 2006?
Provide a short and direct response. 0.9. What is the ratio of the Electricity production(% of total) in World in 2004 to that in 2006?
Provide a short and direct response. 0.84. What is the ratio of the Electricity production(% of total) of Bulgaria in 2004 to that in 2006?
Offer a terse response. 0.05. What is the ratio of the Electricity production(% of total) of Czech Republic in 2004 to that in 2006?
Provide a succinct answer. 0.74. What is the ratio of the Electricity production(% of total) in Low & middle income in 2004 to that in 2007?
Ensure brevity in your answer.  0.83. What is the ratio of the Electricity production(% of total) in World in 2004 to that in 2007?
Give a very brief answer. 0.76. What is the ratio of the Electricity production(% of total) in Bulgaria in 2004 to that in 2007?
Give a very brief answer. 0.02. What is the ratio of the Electricity production(% of total) in Czech Republic in 2004 to that in 2007?
Make the answer very short. 0.57. What is the ratio of the Electricity production(% of total) in Low & middle income in 2004 to that in 2008?
Provide a succinct answer. 0.69. What is the ratio of the Electricity production(% of total) in World in 2004 to that in 2008?
Give a very brief answer. 0.67. What is the ratio of the Electricity production(% of total) of Bulgaria in 2004 to that in 2008?
Your response must be concise. 0.01. What is the ratio of the Electricity production(% of total) in Czech Republic in 2004 to that in 2008?
Provide a short and direct response. 0.42. What is the ratio of the Electricity production(% of total) in Low & middle income in 2004 to that in 2009?
Your answer should be very brief. 0.56. What is the ratio of the Electricity production(% of total) in World in 2004 to that in 2009?
Your answer should be very brief. 0.58. What is the ratio of the Electricity production(% of total) of Bulgaria in 2004 to that in 2009?
Make the answer very short. 0. What is the ratio of the Electricity production(% of total) of Czech Republic in 2004 to that in 2009?
Provide a succinct answer. 0.32. What is the ratio of the Electricity production(% of total) of Low & middle income in 2004 to that in 2010?
Keep it short and to the point. 0.48. What is the ratio of the Electricity production(% of total) of World in 2004 to that in 2010?
Keep it short and to the point. 0.51. What is the ratio of the Electricity production(% of total) in Bulgaria in 2004 to that in 2010?
Ensure brevity in your answer.  0. What is the ratio of the Electricity production(% of total) in Czech Republic in 2004 to that in 2010?
Keep it short and to the point. 0.24. What is the ratio of the Electricity production(% of total) in Low & middle income in 2004 to that in 2011?
Give a very brief answer. 0.42. What is the ratio of the Electricity production(% of total) of World in 2004 to that in 2011?
Give a very brief answer. 0.44. What is the ratio of the Electricity production(% of total) in Bulgaria in 2004 to that in 2011?
Give a very brief answer. 0. What is the ratio of the Electricity production(% of total) in Czech Republic in 2004 to that in 2011?
Offer a very short reply. 0.14. What is the ratio of the Electricity production(% of total) of Low & middle income in 2005 to that in 2006?
Provide a succinct answer. 0.96. What is the ratio of the Electricity production(% of total) of World in 2005 to that in 2006?
Offer a very short reply. 0.92. What is the ratio of the Electricity production(% of total) of Bulgaria in 2005 to that in 2006?
Offer a very short reply. 0.26. What is the ratio of the Electricity production(% of total) in Czech Republic in 2005 to that in 2006?
Make the answer very short. 0.79. What is the ratio of the Electricity production(% of total) in Low & middle income in 2005 to that in 2007?
Keep it short and to the point. 0.88. What is the ratio of the Electricity production(% of total) in World in 2005 to that in 2007?
Give a very brief answer. 0.84. What is the ratio of the Electricity production(% of total) in Bulgaria in 2005 to that in 2007?
Give a very brief answer. 0.1. What is the ratio of the Electricity production(% of total) in Czech Republic in 2005 to that in 2007?
Offer a terse response. 0.61. What is the ratio of the Electricity production(% of total) in Low & middle income in 2005 to that in 2008?
Offer a terse response. 0.73. What is the ratio of the Electricity production(% of total) of World in 2005 to that in 2008?
Your answer should be very brief. 0.73. What is the ratio of the Electricity production(% of total) in Bulgaria in 2005 to that in 2008?
Your response must be concise. 0.04. What is the ratio of the Electricity production(% of total) in Czech Republic in 2005 to that in 2008?
Your response must be concise. 0.45. What is the ratio of the Electricity production(% of total) in Low & middle income in 2005 to that in 2009?
Your answer should be compact. 0.6. What is the ratio of the Electricity production(% of total) in World in 2005 to that in 2009?
Offer a very short reply. 0.63. What is the ratio of the Electricity production(% of total) in Bulgaria in 2005 to that in 2009?
Offer a very short reply. 0.02. What is the ratio of the Electricity production(% of total) in Czech Republic in 2005 to that in 2009?
Offer a very short reply. 0.34. What is the ratio of the Electricity production(% of total) of Low & middle income in 2005 to that in 2010?
Your answer should be very brief. 0.51. What is the ratio of the Electricity production(% of total) of World in 2005 to that in 2010?
Provide a succinct answer. 0.56. What is the ratio of the Electricity production(% of total) of Bulgaria in 2005 to that in 2010?
Provide a succinct answer. 0.01. What is the ratio of the Electricity production(% of total) of Czech Republic in 2005 to that in 2010?
Your answer should be compact. 0.25. What is the ratio of the Electricity production(% of total) of Low & middle income in 2005 to that in 2011?
Make the answer very short. 0.44. What is the ratio of the Electricity production(% of total) of World in 2005 to that in 2011?
Make the answer very short. 0.48. What is the ratio of the Electricity production(% of total) in Bulgaria in 2005 to that in 2011?
Provide a succinct answer. 0.01. What is the ratio of the Electricity production(% of total) in Czech Republic in 2005 to that in 2011?
Your response must be concise. 0.15. What is the ratio of the Electricity production(% of total) of Low & middle income in 2006 to that in 2007?
Your answer should be very brief. 0.92. What is the ratio of the Electricity production(% of total) in World in 2006 to that in 2007?
Offer a very short reply. 0.91. What is the ratio of the Electricity production(% of total) of Bulgaria in 2006 to that in 2007?
Your answer should be compact. 0.4. What is the ratio of the Electricity production(% of total) of Czech Republic in 2006 to that in 2007?
Offer a terse response. 0.77. What is the ratio of the Electricity production(% of total) in Low & middle income in 2006 to that in 2008?
Offer a very short reply. 0.77. What is the ratio of the Electricity production(% of total) of World in 2006 to that in 2008?
Provide a succinct answer. 0.8. What is the ratio of the Electricity production(% of total) of Bulgaria in 2006 to that in 2008?
Provide a short and direct response. 0.14. What is the ratio of the Electricity production(% of total) in Czech Republic in 2006 to that in 2008?
Provide a short and direct response. 0.56. What is the ratio of the Electricity production(% of total) in Low & middle income in 2006 to that in 2009?
Give a very brief answer. 0.62. What is the ratio of the Electricity production(% of total) of World in 2006 to that in 2009?
Give a very brief answer. 0.68. What is the ratio of the Electricity production(% of total) in Bulgaria in 2006 to that in 2009?
Your response must be concise. 0.08. What is the ratio of the Electricity production(% of total) in Czech Republic in 2006 to that in 2009?
Provide a short and direct response. 0.43. What is the ratio of the Electricity production(% of total) of Low & middle income in 2006 to that in 2010?
Offer a terse response. 0.53. What is the ratio of the Electricity production(% of total) in World in 2006 to that in 2010?
Give a very brief answer. 0.6. What is the ratio of the Electricity production(% of total) of Bulgaria in 2006 to that in 2010?
Make the answer very short. 0.03. What is the ratio of the Electricity production(% of total) of Czech Republic in 2006 to that in 2010?
Give a very brief answer. 0.32. What is the ratio of the Electricity production(% of total) in Low & middle income in 2006 to that in 2011?
Provide a short and direct response. 0.46. What is the ratio of the Electricity production(% of total) in World in 2006 to that in 2011?
Your answer should be compact. 0.52. What is the ratio of the Electricity production(% of total) of Bulgaria in 2006 to that in 2011?
Provide a succinct answer. 0.02. What is the ratio of the Electricity production(% of total) of Czech Republic in 2006 to that in 2011?
Provide a short and direct response. 0.19. What is the ratio of the Electricity production(% of total) of Low & middle income in 2007 to that in 2008?
Your answer should be compact. 0.83. What is the ratio of the Electricity production(% of total) of World in 2007 to that in 2008?
Offer a very short reply. 0.88. What is the ratio of the Electricity production(% of total) of Bulgaria in 2007 to that in 2008?
Provide a short and direct response. 0.35. What is the ratio of the Electricity production(% of total) of Czech Republic in 2007 to that in 2008?
Your response must be concise. 0.73. What is the ratio of the Electricity production(% of total) of Low & middle income in 2007 to that in 2009?
Provide a short and direct response. 0.68. What is the ratio of the Electricity production(% of total) in World in 2007 to that in 2009?
Your answer should be compact. 0.75. What is the ratio of the Electricity production(% of total) in Bulgaria in 2007 to that in 2009?
Keep it short and to the point. 0.19. What is the ratio of the Electricity production(% of total) in Czech Republic in 2007 to that in 2009?
Offer a terse response. 0.55. What is the ratio of the Electricity production(% of total) of Low & middle income in 2007 to that in 2010?
Your answer should be compact. 0.58. What is the ratio of the Electricity production(% of total) in World in 2007 to that in 2010?
Offer a terse response. 0.67. What is the ratio of the Electricity production(% of total) of Bulgaria in 2007 to that in 2010?
Your answer should be compact. 0.07. What is the ratio of the Electricity production(% of total) of Czech Republic in 2007 to that in 2010?
Your answer should be compact. 0.41. What is the ratio of the Electricity production(% of total) in Low & middle income in 2007 to that in 2011?
Offer a very short reply. 0.5. What is the ratio of the Electricity production(% of total) in World in 2007 to that in 2011?
Give a very brief answer. 0.58. What is the ratio of the Electricity production(% of total) of Bulgaria in 2007 to that in 2011?
Ensure brevity in your answer.  0.05. What is the ratio of the Electricity production(% of total) in Czech Republic in 2007 to that in 2011?
Your response must be concise. 0.25. What is the ratio of the Electricity production(% of total) of Low & middle income in 2008 to that in 2009?
Your answer should be very brief. 0.82. What is the ratio of the Electricity production(% of total) of World in 2008 to that in 2009?
Your response must be concise. 0.86. What is the ratio of the Electricity production(% of total) in Bulgaria in 2008 to that in 2009?
Give a very brief answer. 0.53. What is the ratio of the Electricity production(% of total) of Czech Republic in 2008 to that in 2009?
Offer a terse response. 0.75. What is the ratio of the Electricity production(% of total) of Low & middle income in 2008 to that in 2010?
Your response must be concise. 0.7. What is the ratio of the Electricity production(% of total) in World in 2008 to that in 2010?
Offer a very short reply. 0.76. What is the ratio of the Electricity production(% of total) of Bulgaria in 2008 to that in 2010?
Keep it short and to the point. 0.19. What is the ratio of the Electricity production(% of total) of Czech Republic in 2008 to that in 2010?
Offer a very short reply. 0.56. What is the ratio of the Electricity production(% of total) of Low & middle income in 2008 to that in 2011?
Offer a very short reply. 0.6. What is the ratio of the Electricity production(% of total) of World in 2008 to that in 2011?
Give a very brief answer. 0.66. What is the ratio of the Electricity production(% of total) of Bulgaria in 2008 to that in 2011?
Provide a short and direct response. 0.15. What is the ratio of the Electricity production(% of total) in Czech Republic in 2008 to that in 2011?
Give a very brief answer. 0.34. What is the ratio of the Electricity production(% of total) of Low & middle income in 2009 to that in 2010?
Your answer should be compact. 0.86. What is the ratio of the Electricity production(% of total) in World in 2009 to that in 2010?
Your answer should be very brief. 0.88. What is the ratio of the Electricity production(% of total) of Bulgaria in 2009 to that in 2010?
Make the answer very short. 0.37. What is the ratio of the Electricity production(% of total) of Czech Republic in 2009 to that in 2010?
Offer a terse response. 0.75. What is the ratio of the Electricity production(% of total) in Low & middle income in 2009 to that in 2011?
Provide a succinct answer. 0.74. What is the ratio of the Electricity production(% of total) in World in 2009 to that in 2011?
Your answer should be compact. 0.77. What is the ratio of the Electricity production(% of total) in Bulgaria in 2009 to that in 2011?
Your response must be concise. 0.29. What is the ratio of the Electricity production(% of total) in Czech Republic in 2009 to that in 2011?
Keep it short and to the point. 0.45. What is the ratio of the Electricity production(% of total) in Low & middle income in 2010 to that in 2011?
Provide a short and direct response. 0.87. What is the ratio of the Electricity production(% of total) in World in 2010 to that in 2011?
Give a very brief answer. 0.87. What is the ratio of the Electricity production(% of total) of Bulgaria in 2010 to that in 2011?
Ensure brevity in your answer.  0.78. What is the ratio of the Electricity production(% of total) in Czech Republic in 2010 to that in 2011?
Offer a terse response. 0.6. What is the difference between the highest and the second highest Electricity production(% of total) in Low & middle income?
Provide a succinct answer. 0.33. What is the difference between the highest and the second highest Electricity production(% of total) in World?
Make the answer very short. 0.56. What is the difference between the highest and the second highest Electricity production(% of total) of Bulgaria?
Provide a succinct answer. 0.44. What is the difference between the highest and the second highest Electricity production(% of total) in Czech Republic?
Offer a very short reply. 2.44. What is the difference between the highest and the lowest Electricity production(% of total) in Low & middle income?
Keep it short and to the point. 1.46. What is the difference between the highest and the lowest Electricity production(% of total) of World?
Make the answer very short. 2.32. What is the difference between the highest and the lowest Electricity production(% of total) in Bulgaria?
Offer a very short reply. 2.03. What is the difference between the highest and the lowest Electricity production(% of total) of Czech Republic?
Your answer should be very brief. 5.22. 